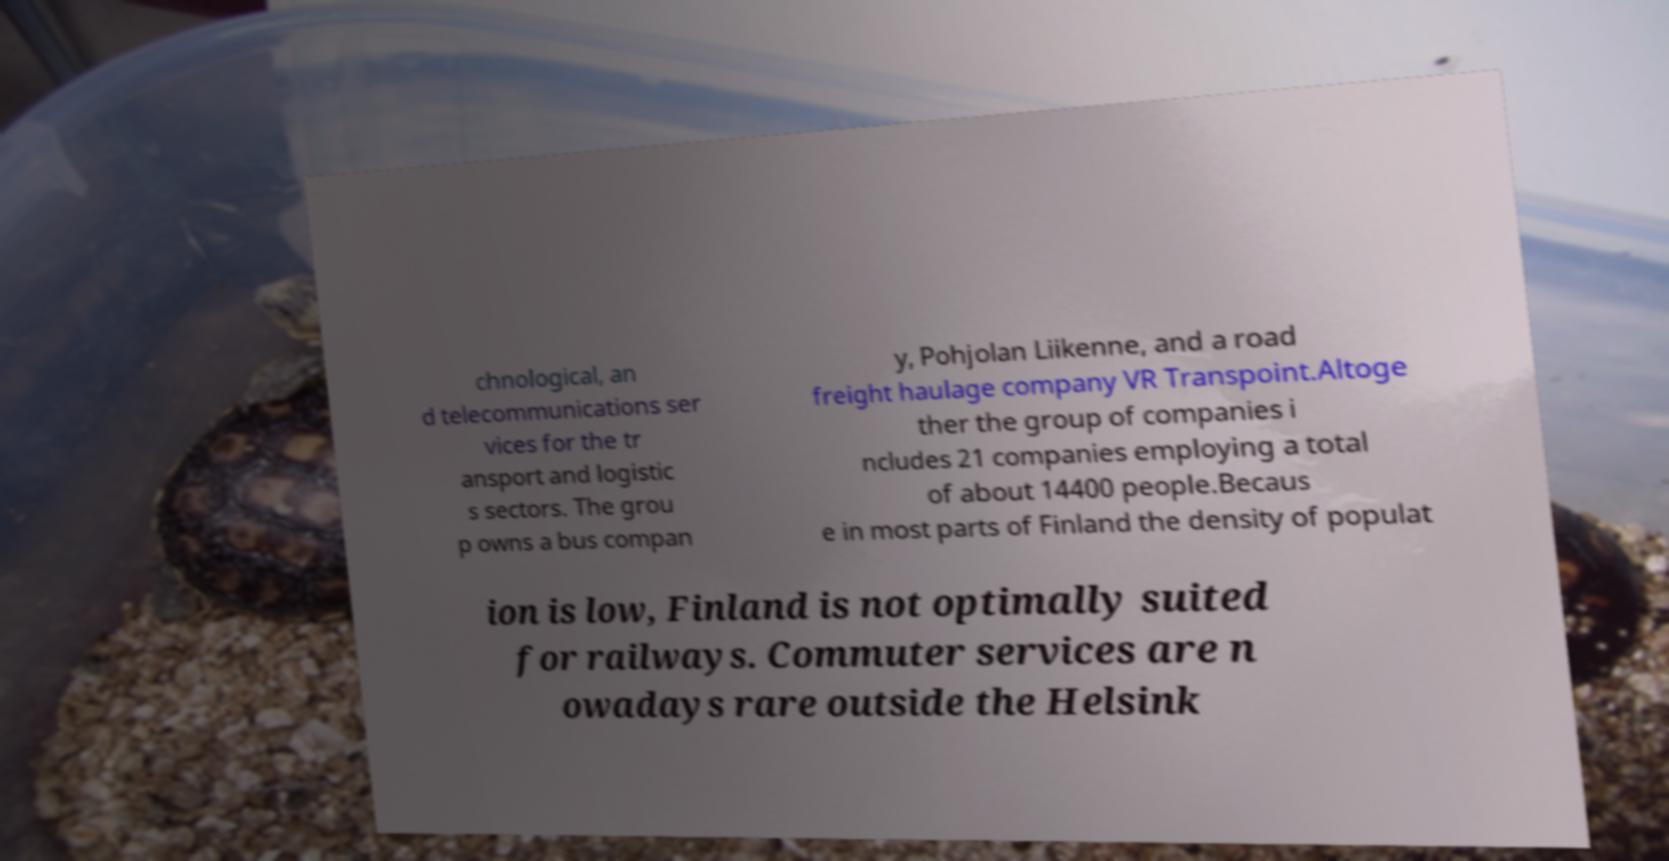Could you assist in decoding the text presented in this image and type it out clearly? chnological, an d telecommunications ser vices for the tr ansport and logistic s sectors. The grou p owns a bus compan y, Pohjolan Liikenne, and a road freight haulage company VR Transpoint.Altoge ther the group of companies i ncludes 21 companies employing a total of about 14400 people.Becaus e in most parts of Finland the density of populat ion is low, Finland is not optimally suited for railways. Commuter services are n owadays rare outside the Helsink 